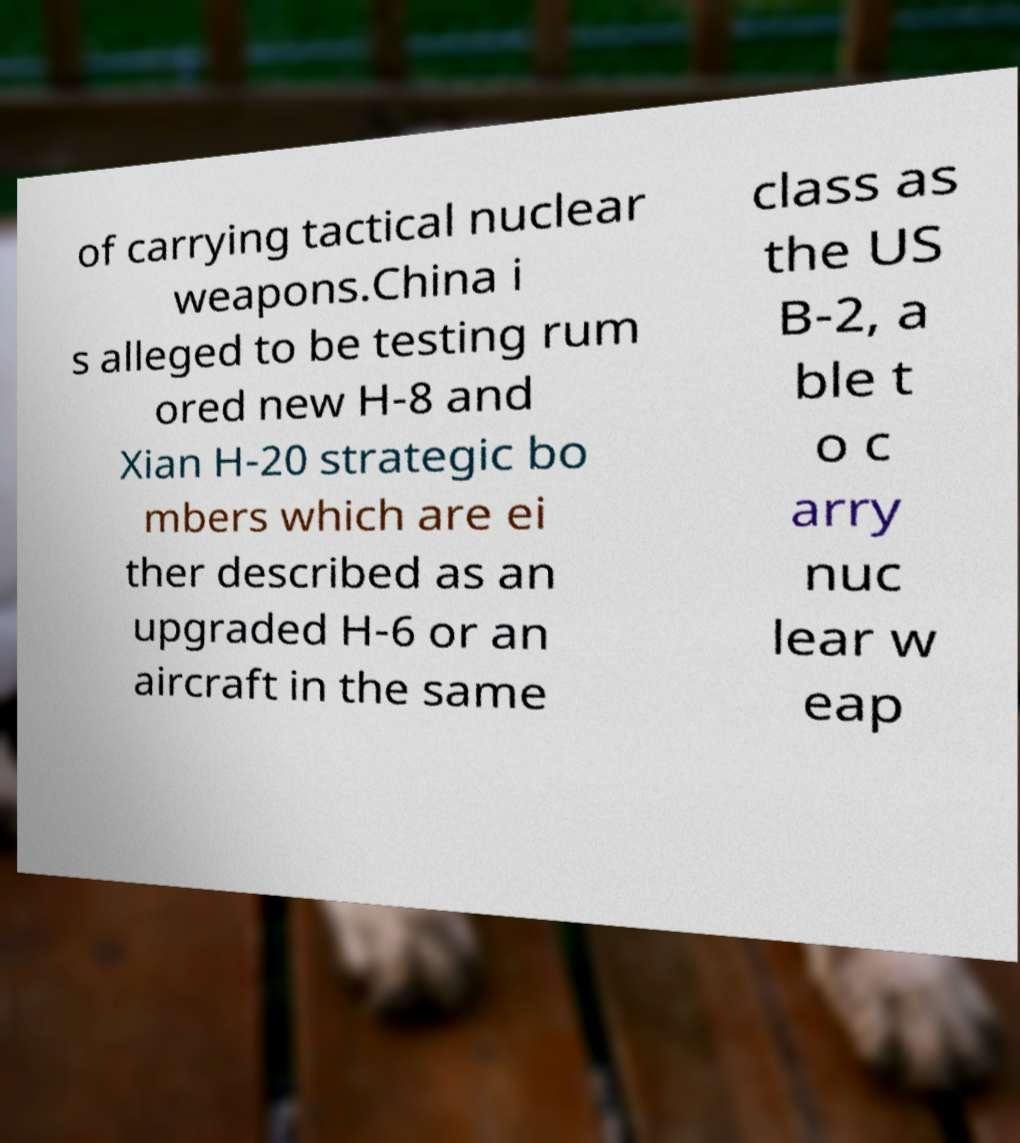What messages or text are displayed in this image? I need them in a readable, typed format. of carrying tactical nuclear weapons.China i s alleged to be testing rum ored new H-8 and Xian H-20 strategic bo mbers which are ei ther described as an upgraded H-6 or an aircraft in the same class as the US B-2, a ble t o c arry nuc lear w eap 